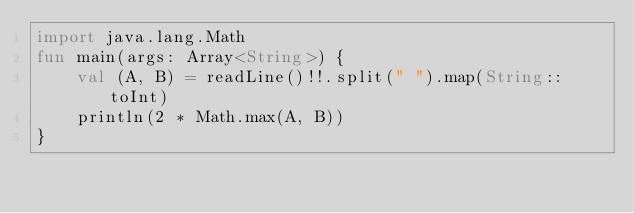<code> <loc_0><loc_0><loc_500><loc_500><_Kotlin_>import java.lang.Math
fun main(args: Array<String>) {
    val (A, B) = readLine()!!.split(" ").map(String::toInt)
    println(2 * Math.max(A, B))
}</code> 